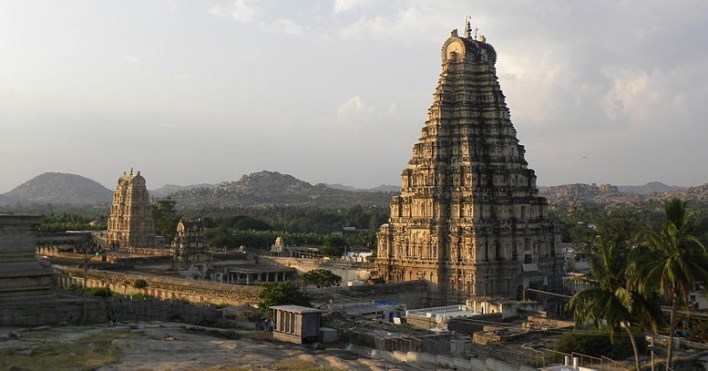Are there any interesting legends associated with the temple? Yes, the Virupaksha Temple is steeped in mythology and legends. One such tale is about the temple's divine origin, which states it was believed to be constructed by Lord Shiva himself. According to another beloved local legend, the temple has a sacred river flowing upside down beneath it, signifying the hidden divine powers. Furthermore, the temple celebrates the puranic legend of Lord Shiva's marriage to Goddess Pampa, and the annual festivities of the marriage attract scores of devotees year after year. 